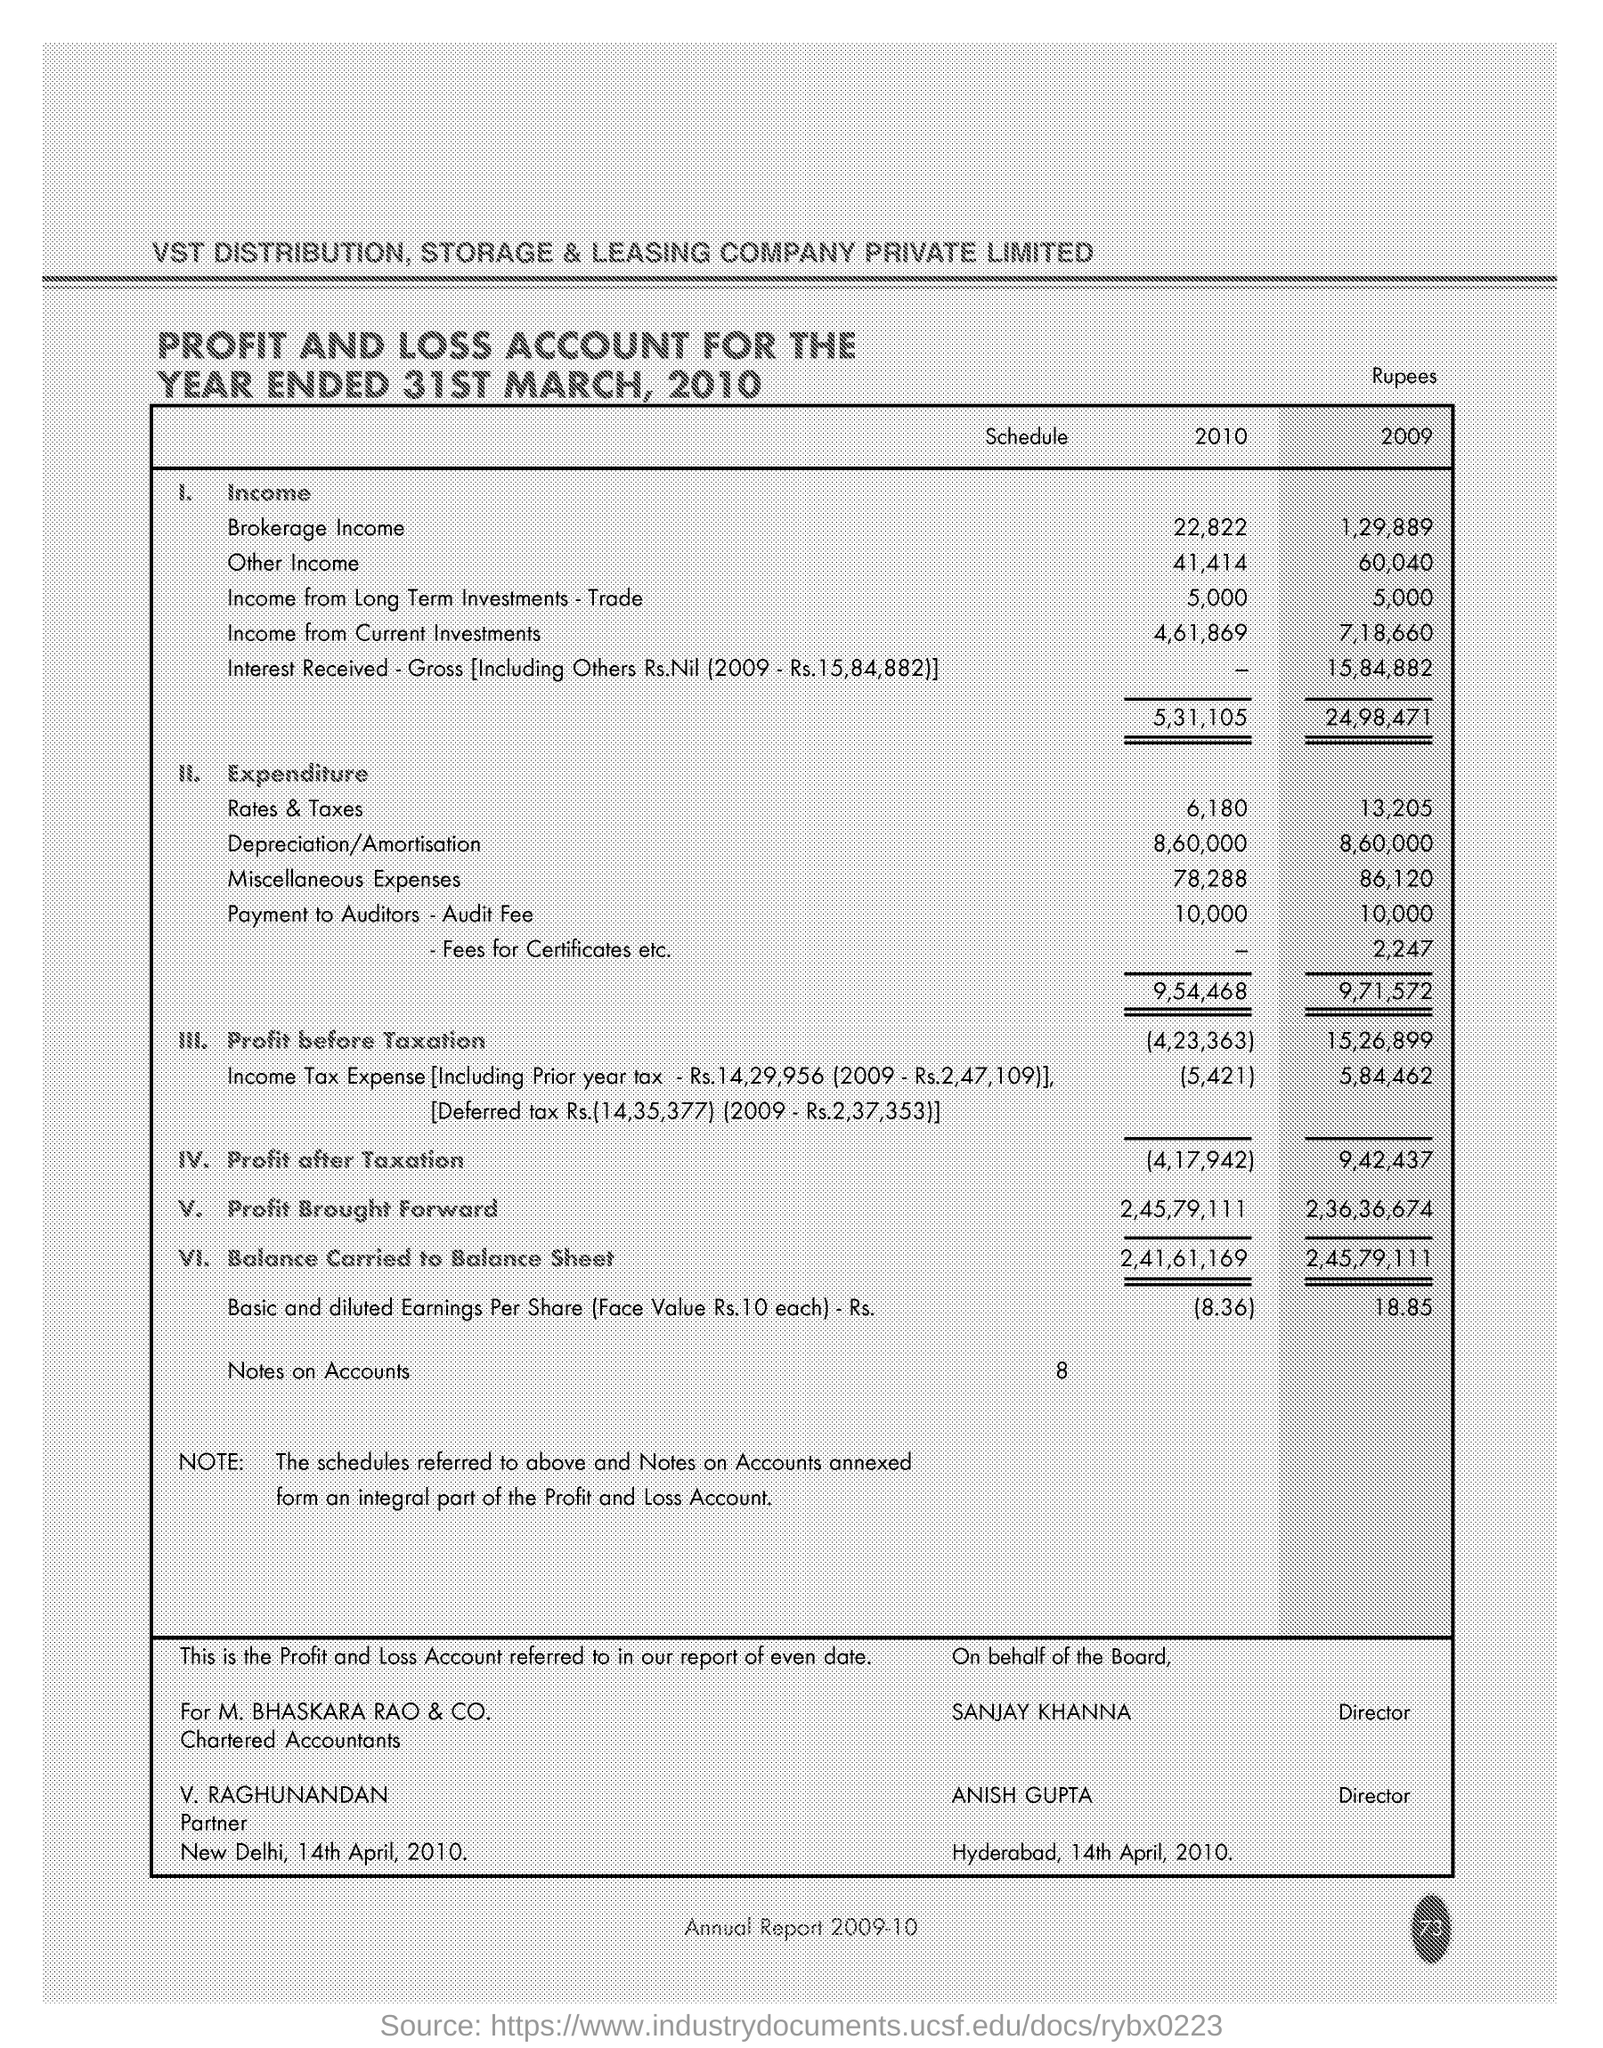Which year is having more expenditure while comparing of 2010 and 2009
Give a very brief answer. 2009. According to Profit and Loss Account What is brokerage income in 2010?
Provide a succinct answer. 22,822. 